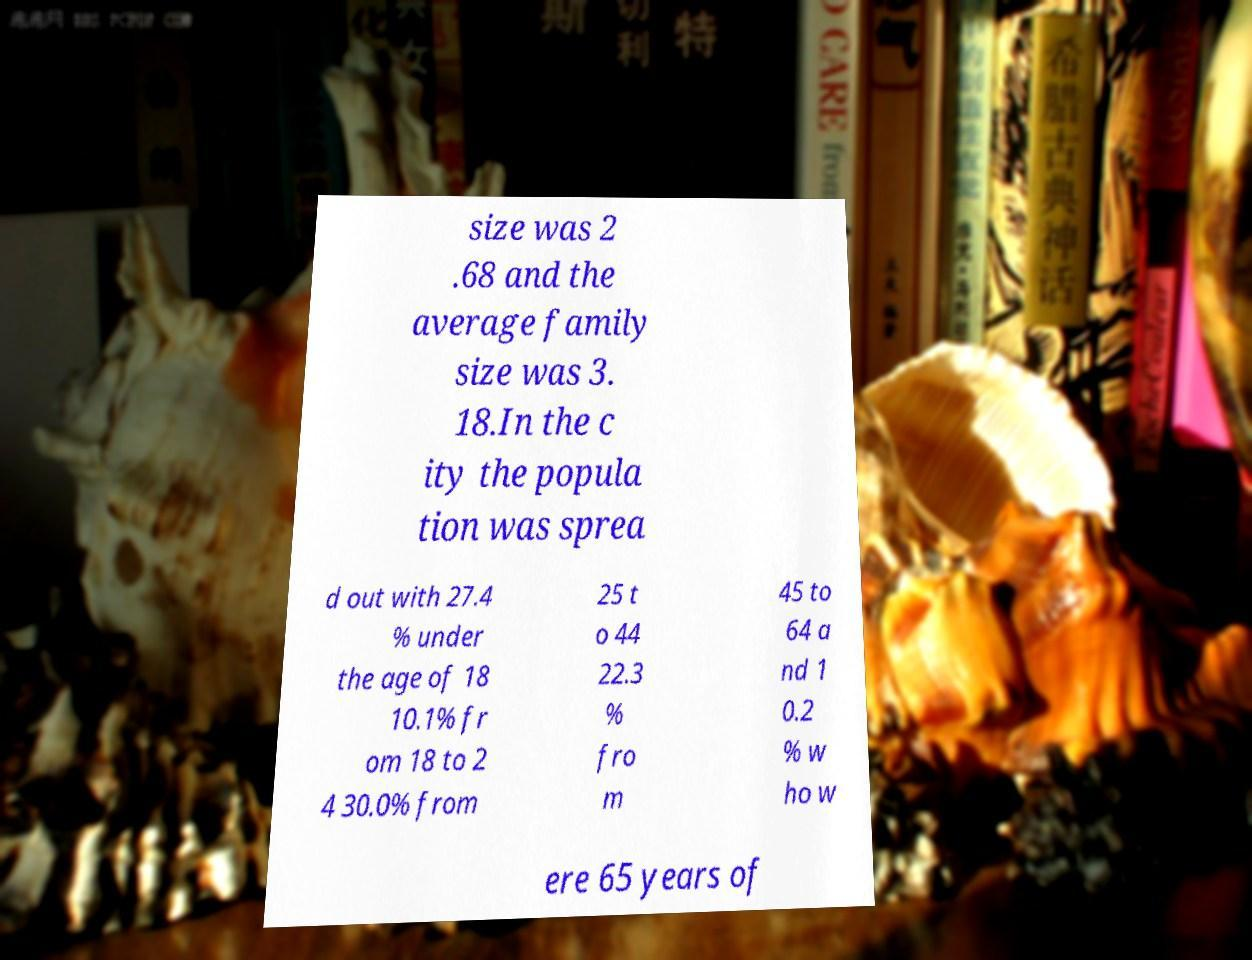Please read and relay the text visible in this image. What does it say? size was 2 .68 and the average family size was 3. 18.In the c ity the popula tion was sprea d out with 27.4 % under the age of 18 10.1% fr om 18 to 2 4 30.0% from 25 t o 44 22.3 % fro m 45 to 64 a nd 1 0.2 % w ho w ere 65 years of 